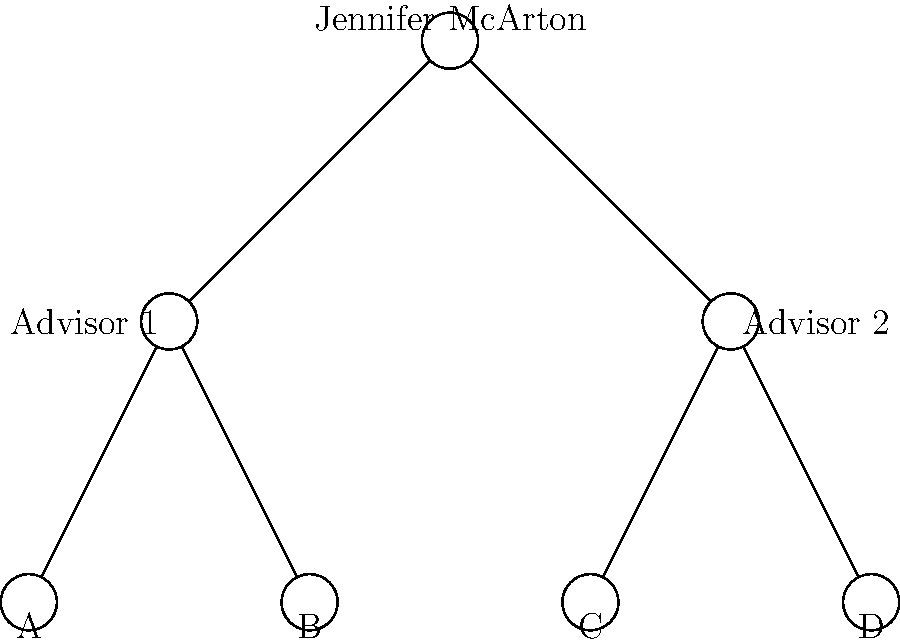Based on the academic lineage diagram, how many "academic grandparents" are represented in your family tree-style illustration? To determine the number of "academic grandparents" in the diagram, we need to follow these steps:

1. Identify the root of the tree: Jennifer McArton (you) is at the top.
2. Identify your direct academic advisors: There are two advisors directly below you, labeled "Advisor 1" and "Advisor 2".
3. Count the number of individuals one level below your advisors: These would be your "academic grandparents".
   - Under "Advisor 1", there are two individuals (A and B).
   - Under "Advisor 2", there are two individuals (C and D).
4. Sum up the total number of individuals at this level: 2 + 2 = 4.

Therefore, the diagram represents 4 "academic grandparents" in your academic lineage.
Answer: 4 